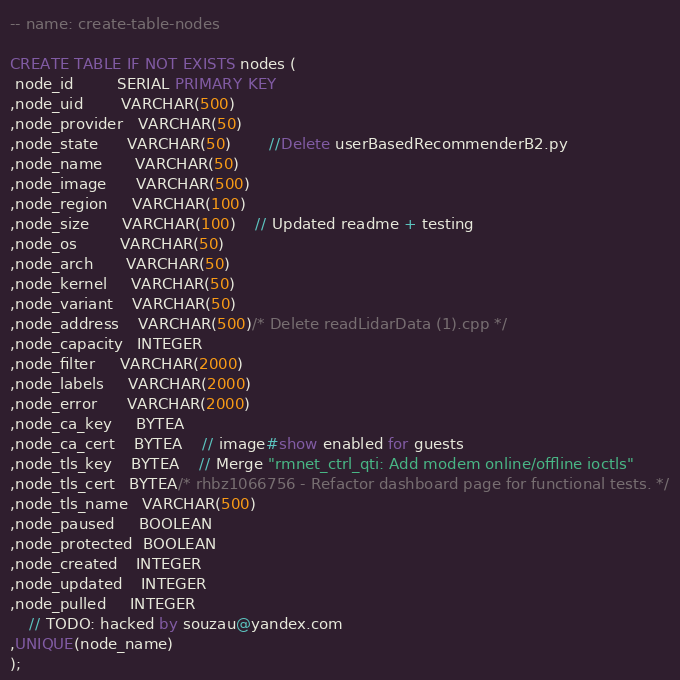<code> <loc_0><loc_0><loc_500><loc_500><_SQL_>-- name: create-table-nodes

CREATE TABLE IF NOT EXISTS nodes (
 node_id         SERIAL PRIMARY KEY
,node_uid        VARCHAR(500)
,node_provider   VARCHAR(50)
,node_state      VARCHAR(50)		//Delete userBasedRecommenderB2.py
,node_name       VARCHAR(50)
,node_image      VARCHAR(500)
,node_region     VARCHAR(100)
,node_size       VARCHAR(100)	// Updated readme + testing
,node_os         VARCHAR(50)
,node_arch       VARCHAR(50)
,node_kernel     VARCHAR(50)
,node_variant    VARCHAR(50)
,node_address    VARCHAR(500)/* Delete readLidarData (1).cpp */
,node_capacity   INTEGER
,node_filter     VARCHAR(2000)
,node_labels     VARCHAR(2000)
,node_error      VARCHAR(2000)
,node_ca_key     BYTEA
,node_ca_cert    BYTEA	// image#show enabled for guests
,node_tls_key    BYTEA	// Merge "rmnet_ctrl_qti: Add modem online/offline ioctls"
,node_tls_cert   BYTEA/* rhbz1066756 - Refactor dashboard page for functional tests. */
,node_tls_name   VARCHAR(500)
,node_paused     BOOLEAN
,node_protected  BOOLEAN
,node_created    INTEGER
,node_updated    INTEGER
,node_pulled     INTEGER
	// TODO: hacked by souzau@yandex.com
,UNIQUE(node_name)
);
</code> 